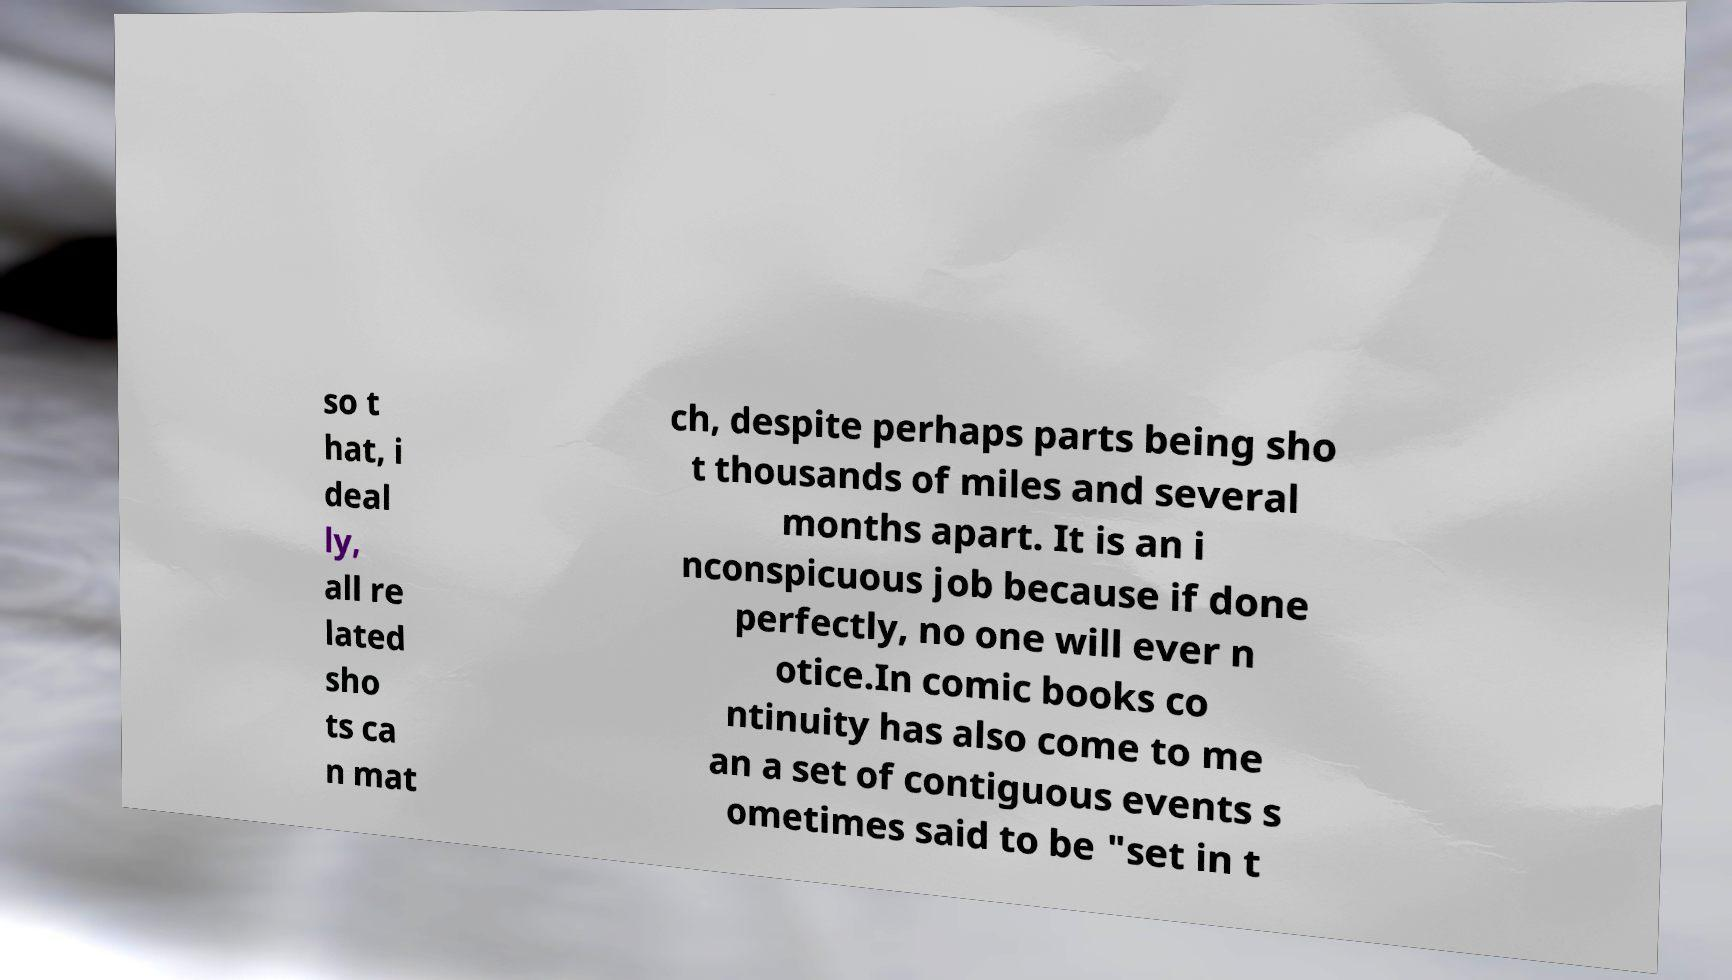Could you assist in decoding the text presented in this image and type it out clearly? so t hat, i deal ly, all re lated sho ts ca n mat ch, despite perhaps parts being sho t thousands of miles and several months apart. It is an i nconspicuous job because if done perfectly, no one will ever n otice.In comic books co ntinuity has also come to me an a set of contiguous events s ometimes said to be "set in t 